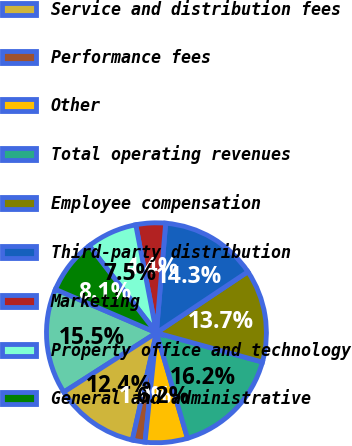Convert chart. <chart><loc_0><loc_0><loc_500><loc_500><pie_chart><fcel>Investment management fees<fcel>Service and distribution fees<fcel>Performance fees<fcel>Other<fcel>Total operating revenues<fcel>Employee compensation<fcel>Third-party distribution<fcel>Marketing<fcel>Property office and technology<fcel>General and administrative<nl><fcel>15.53%<fcel>12.42%<fcel>1.86%<fcel>6.21%<fcel>16.15%<fcel>13.66%<fcel>14.29%<fcel>4.35%<fcel>7.45%<fcel>8.07%<nl></chart> 